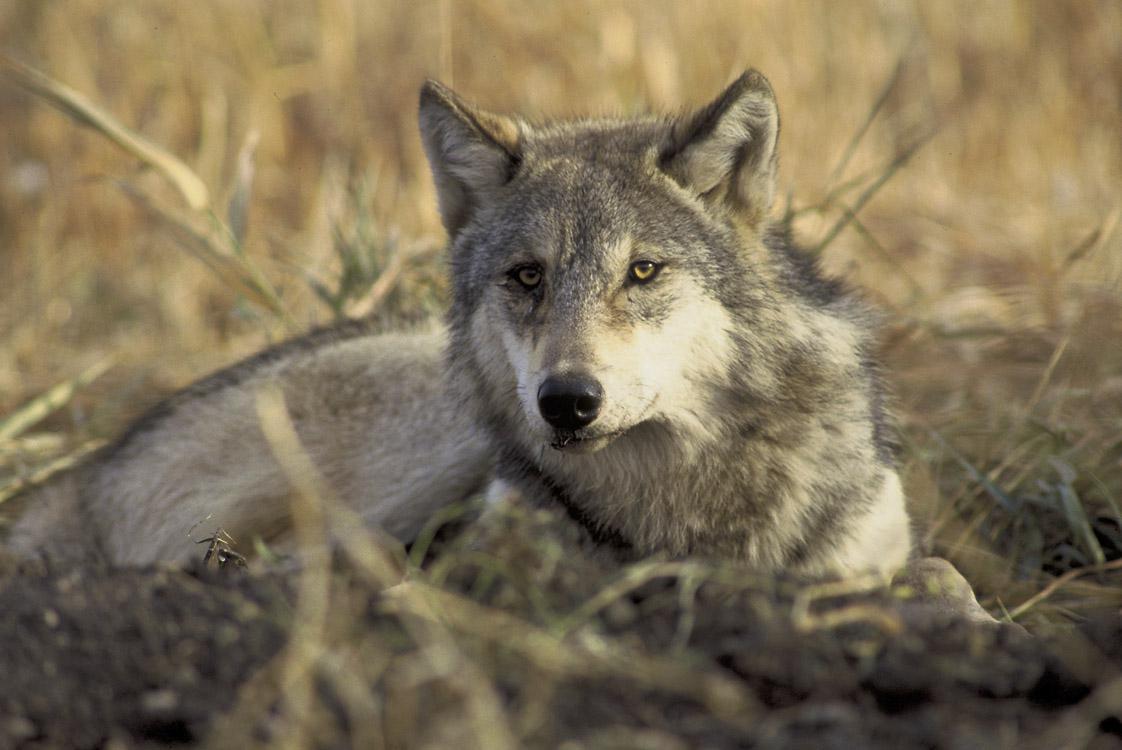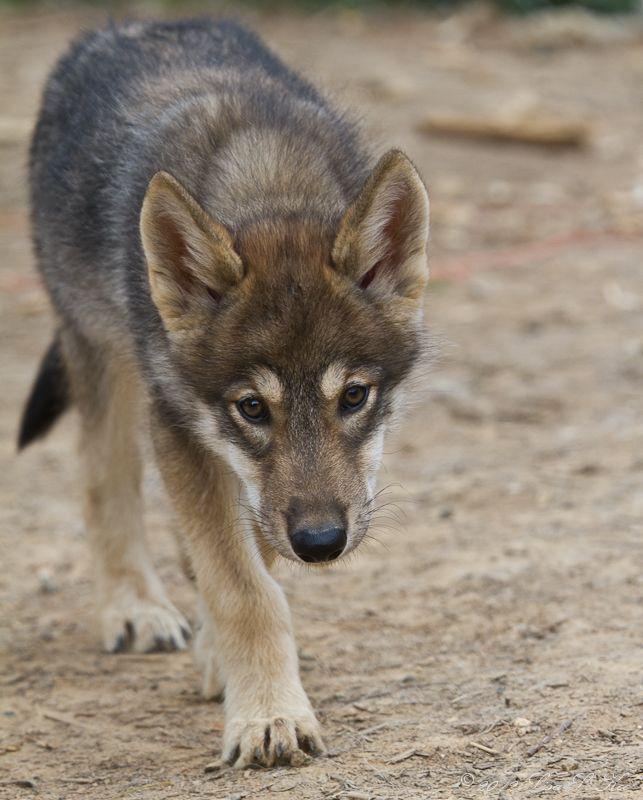The first image is the image on the left, the second image is the image on the right. Given the left and right images, does the statement "Fencing is in the background of one image." hold true? Answer yes or no. No. The first image is the image on the left, the second image is the image on the right. Considering the images on both sides, is "Left image contains two dogs and right image contains one dog." valid? Answer yes or no. No. 